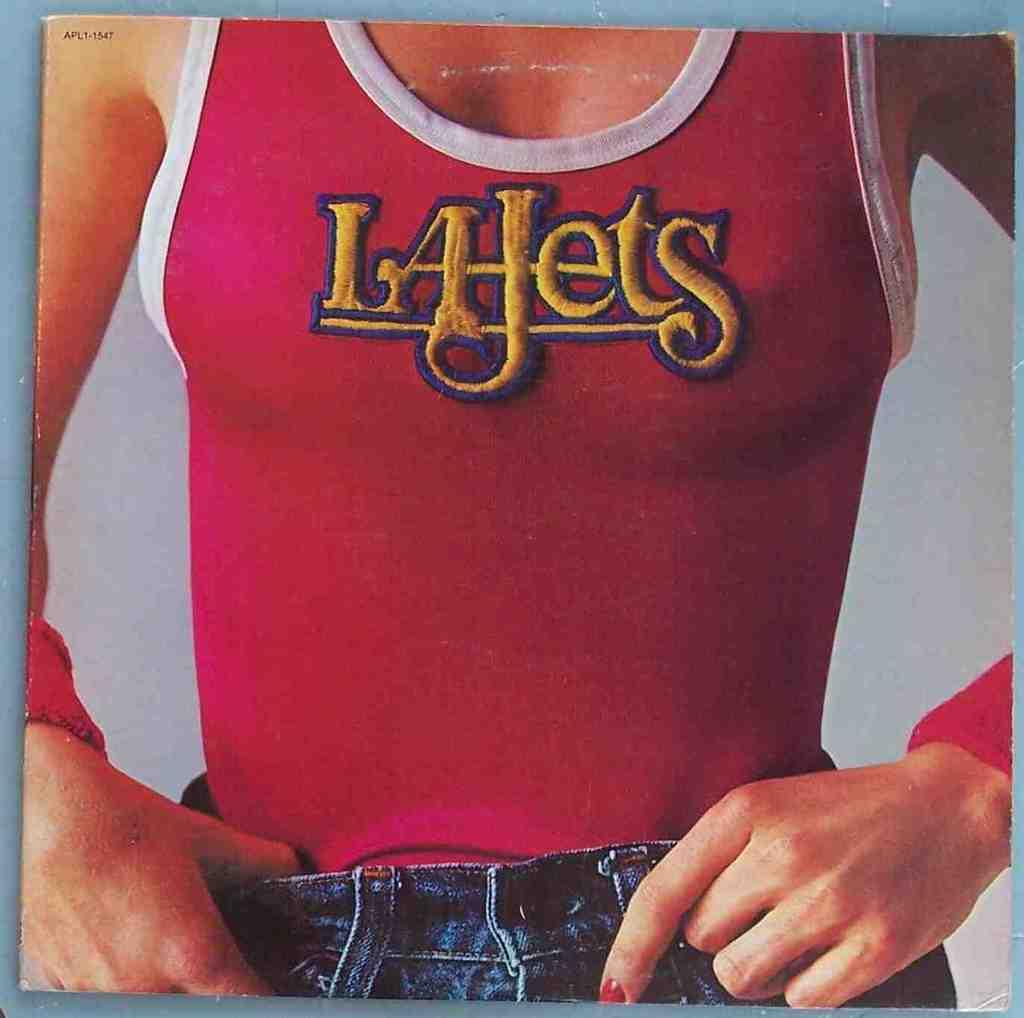Who is present in the image? There is a woman in the image. What type of clothing is the woman wearing? The woman is wearing a vest and jeans. What can be seen in the background of the image? There is a plane in the background of the image. Can you see a frog hopping near the woman in the image? No, there is no frog present in the image. What type of trousers is the woman wearing? The woman is wearing jeans, which are a type of trousers. However, the question is slightly misleading as we already mentioned that the woman is wearing jeans in the conversation. 